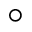Convert formula to latex. <formula><loc_0><loc_0><loc_500><loc_500>\circ</formula> 